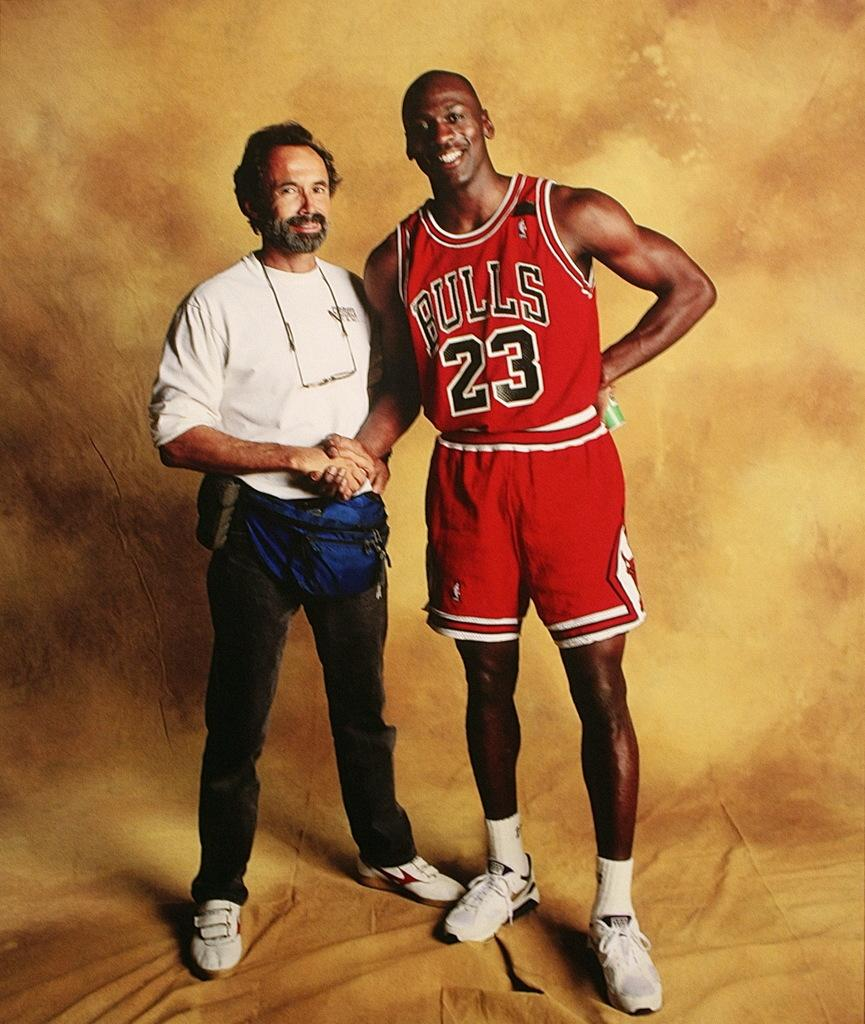Provide a one-sentence caption for the provided image. Michael Jordan wears a Bulls jersey and shakes someone's hand. 